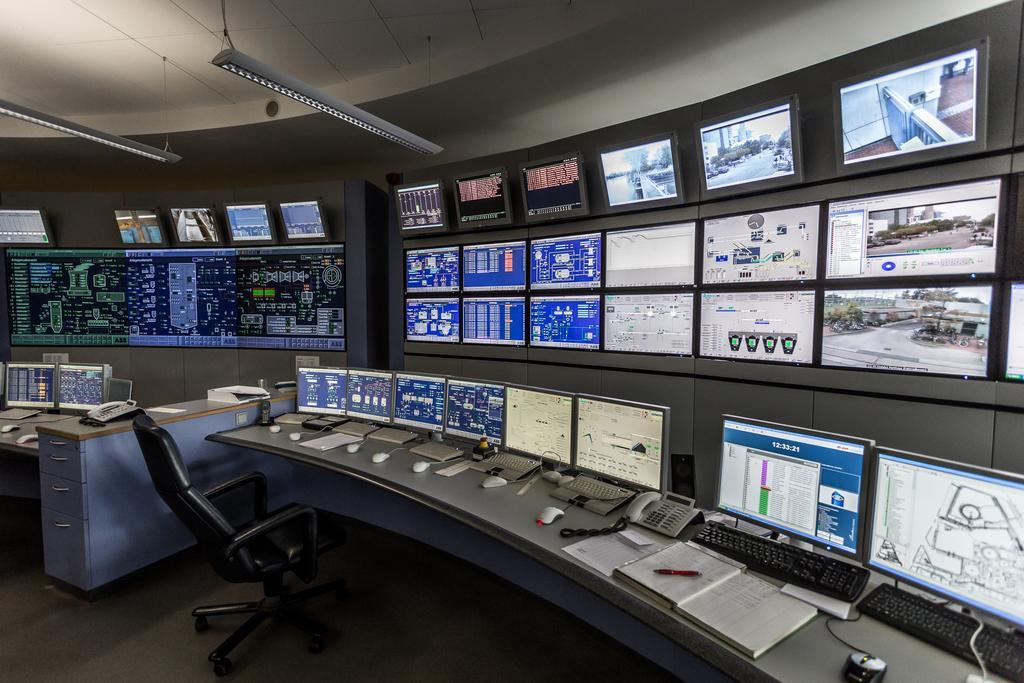Please provide a concise description of this image. I think this image is taken in the control room. These are the screens attached to the wall. This is the table with monitors,keyboards,mouses,phone,book and few other things on it. This is a chair which is black in color. These are the tube lights hanging to the rooftop. 